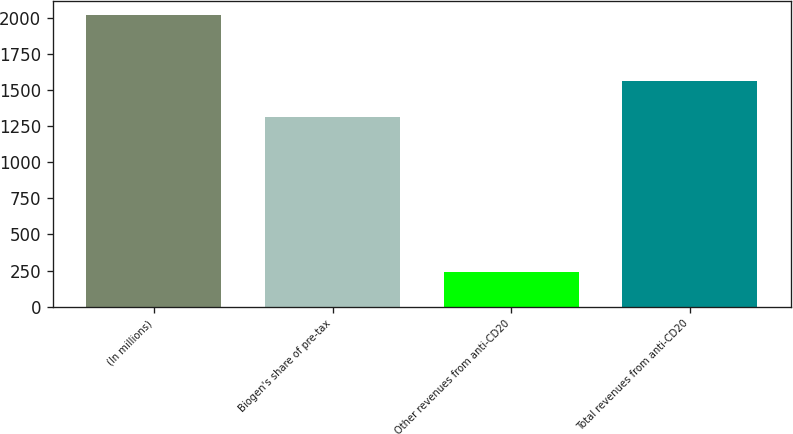Convert chart. <chart><loc_0><loc_0><loc_500><loc_500><bar_chart><fcel>(In millions)<fcel>Biogen's share of pre-tax<fcel>Other revenues from anti-CD20<fcel>Total revenues from anti-CD20<nl><fcel>2017<fcel>1316.4<fcel>242.8<fcel>1559.2<nl></chart> 